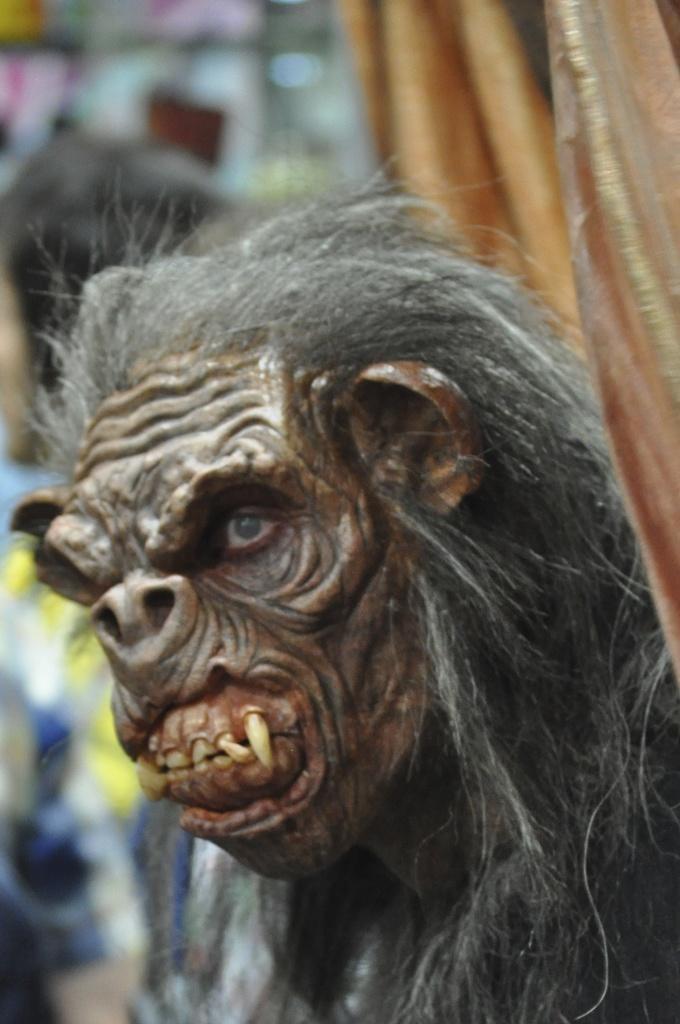Please provide a concise description of this image. There is a statue of a gorilla. In the background it is blur. 